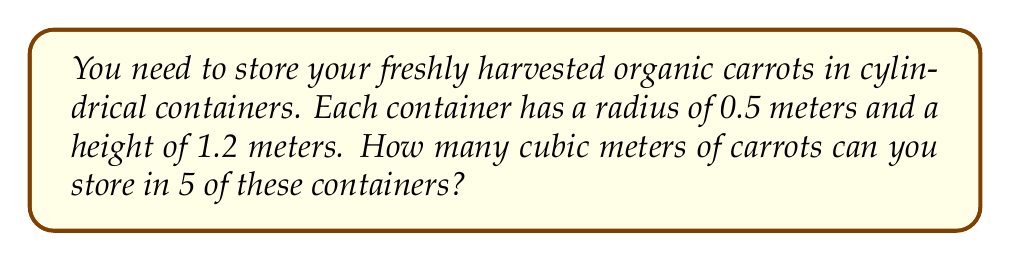Provide a solution to this math problem. To solve this problem, we need to follow these steps:

1. Calculate the volume of one cylindrical container:
   The formula for the volume of a cylinder is $V = \pi r^2 h$, where:
   $r$ is the radius of the base
   $h$ is the height of the cylinder

   Given:
   $r = 0.5$ meters
   $h = 1.2$ meters

   Substituting these values:
   $$V = \pi (0.5)^2 (1.2)$$
   $$V = \pi (0.25) (1.2)$$
   $$V = 0.3\pi$$

2. Simplify the expression:
   $$V \approx 0.9425 \text{ cubic meters}$$

3. Calculate the total volume for 5 containers:
   $$\text{Total Volume} = 5 \times 0.9425$$
   $$\text{Total Volume} = 4.7125 \text{ cubic meters}$$

Therefore, you can store approximately 4.7125 cubic meters of carrots in 5 containers.
Answer: 4.7125 cubic meters 